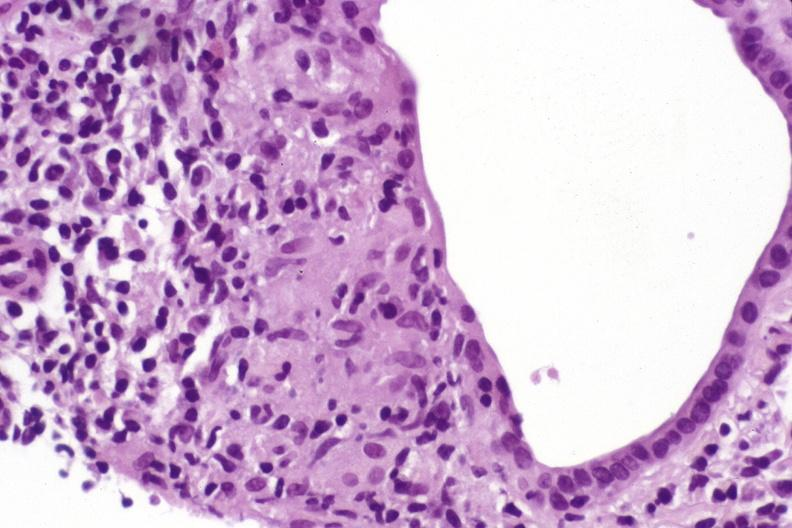does this image show primary biliary cirrhosis?
Answer the question using a single word or phrase. Yes 